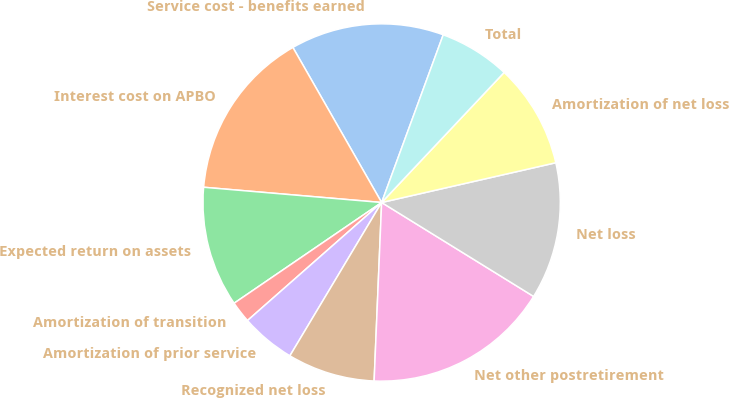<chart> <loc_0><loc_0><loc_500><loc_500><pie_chart><fcel>Service cost - benefits earned<fcel>Interest cost on APBO<fcel>Expected return on assets<fcel>Amortization of transition<fcel>Amortization of prior service<fcel>Recognized net loss<fcel>Net other postretirement<fcel>Net loss<fcel>Amortization of net loss<fcel>Total<nl><fcel>13.87%<fcel>15.36%<fcel>10.89%<fcel>1.95%<fcel>4.93%<fcel>7.91%<fcel>16.85%<fcel>12.38%<fcel>9.4%<fcel>6.42%<nl></chart> 